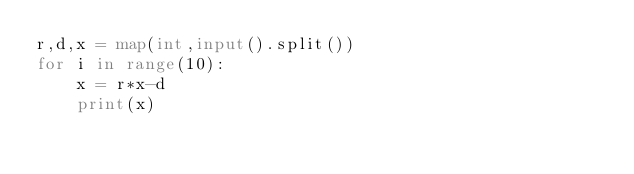<code> <loc_0><loc_0><loc_500><loc_500><_Python_>r,d,x = map(int,input().split())
for i in range(10):
    x = r*x-d
    print(x)</code> 